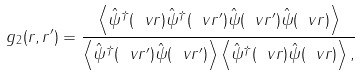<formula> <loc_0><loc_0><loc_500><loc_500>g _ { 2 } ( { r } , { r } ^ { \prime } ) = \frac { \left < \hat { \psi } ^ { \dagger } ( \ v { r } ) \hat { \psi } ^ { \dagger } ( \ v { r ^ { \prime } } ) \hat { \psi } ( \ v { r ^ { \prime } } ) \hat { \psi } ( \ v { r } ) \right > } { \left < \hat { \psi } ^ { \dagger } ( \ v { r ^ { \prime } } ) \hat { \psi } ( \ v { r ^ { \prime } } ) \right > \left < \hat { \psi } ^ { \dagger } ( \ v { r } ) \hat { \psi } ( \ v { r } ) \right > , }</formula> 